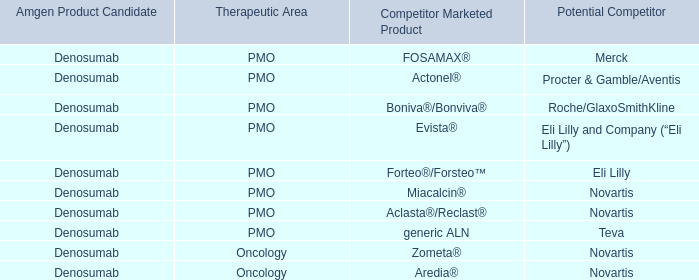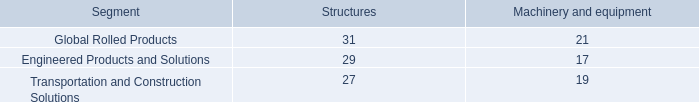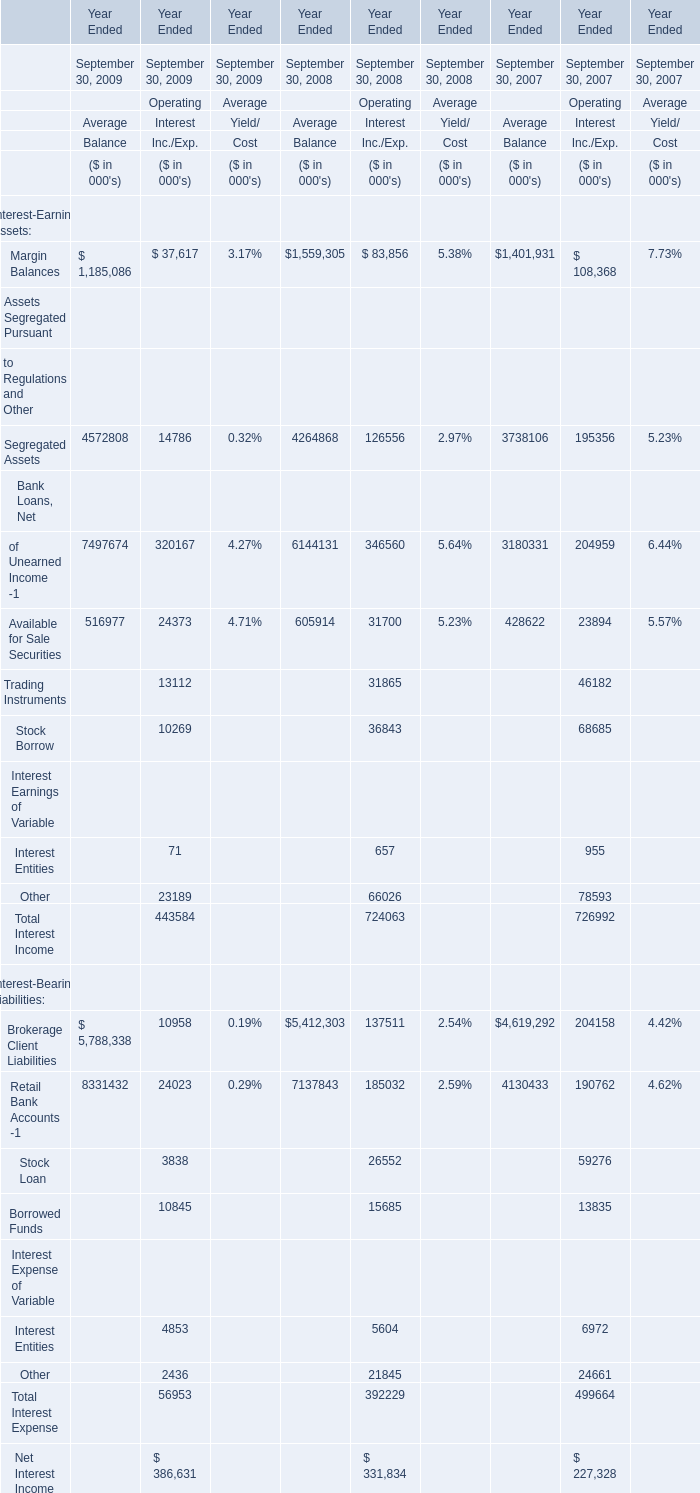What was the average value of theSegregated Assets for Balance in the years where Margin Balances is positive? 
Computations: (((4572808 + 4264868) + 3738106) / 3)
Answer: 4191927.33333. 